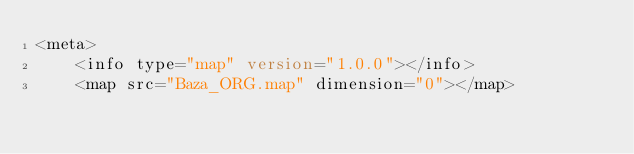<code> <loc_0><loc_0><loc_500><loc_500><_XML_><meta>
    <info type="map" version="1.0.0"></info>
    <map src="Baza_ORG.map" dimension="0"></map></code> 